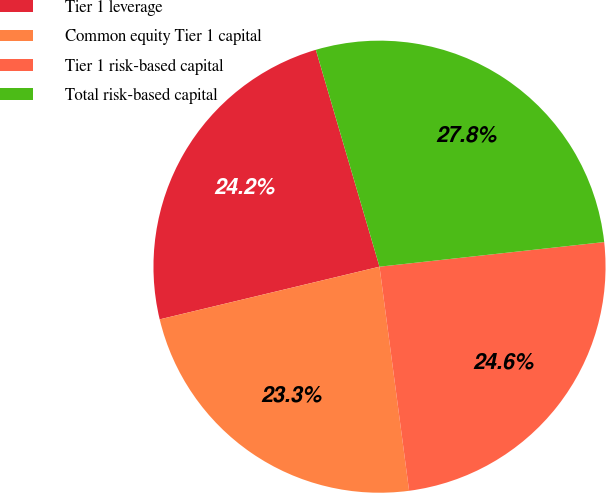<chart> <loc_0><loc_0><loc_500><loc_500><pie_chart><fcel>Tier 1 leverage<fcel>Common equity Tier 1 capital<fcel>Tier 1 risk-based capital<fcel>Total risk-based capital<nl><fcel>24.2%<fcel>23.35%<fcel>24.65%<fcel>27.81%<nl></chart> 